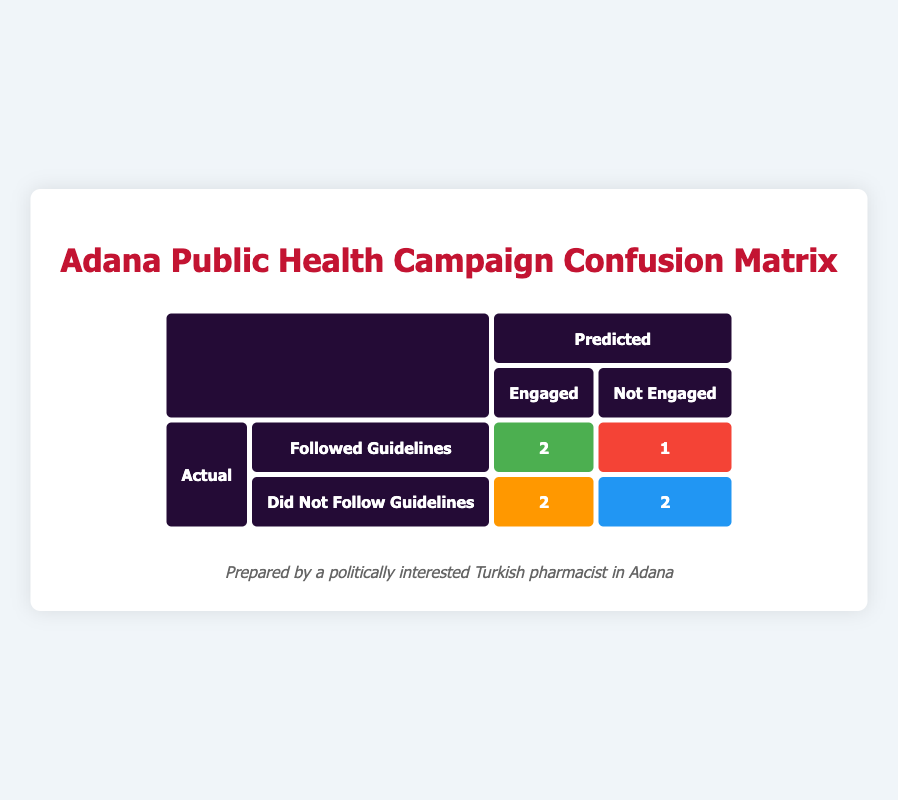What is the total number of true positives in the confusion matrix? The true positives represent the count of individuals who were both engaged and followed the guidelines. According to the matrix, there are 2 true positives.
Answer: 2 How many individuals did not follow the guidelines but were predicted to be engaged? The false positives indicate individuals who were engaged but did not follow the guidelines. The confusion matrix shows there are 2 such individuals.
Answer: 2 What is the total number of individuals who were engaged in the campaigns? The engaged individuals are categorized into true positives and false positives. Summing them gives 2 (true positives) + 2 (false positives) = 4 engaged individuals.
Answer: 4 How many individuals followed the guidelines but were not predicted to be engaged? The false negatives show those who followed the guidelines but were not engaged. There is 1 individual in this category as per the matrix.
Answer: 1 Did any individuals both not engage and not follow the guidelines? Yes, the true negatives indicate individuals who neither engaged nor followed the guidelines. The confusion matrix shows there are 2 such individuals.
Answer: Yes 